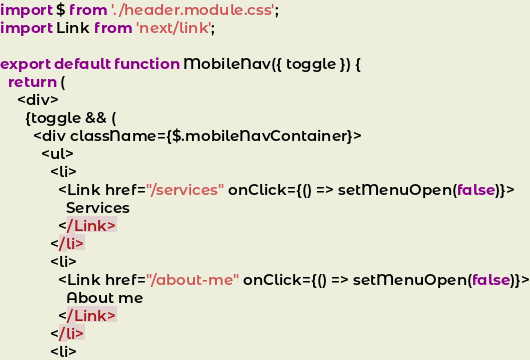<code> <loc_0><loc_0><loc_500><loc_500><_JavaScript_>import $ from './header.module.css';
import Link from 'next/link';

export default function MobileNav({ toggle }) {
  return (
    <div>
      {toggle && (
        <div className={$.mobileNavContainer}>
          <ul>
            <li>
              <Link href="/services" onClick={() => setMenuOpen(false)}>
                Services
              </Link>
            </li>
            <li>
              <Link href="/about-me" onClick={() => setMenuOpen(false)}>
                About me
              </Link>
            </li>
            <li></code> 